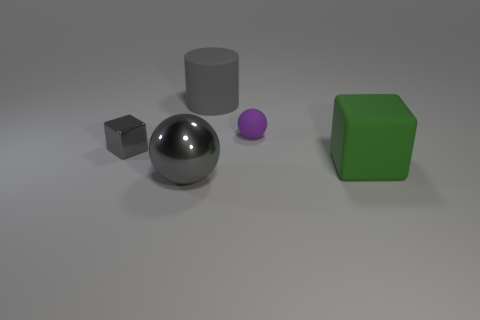Add 3 big blocks. How many objects exist? 8 Subtract all spheres. How many objects are left? 3 Subtract all big things. Subtract all purple objects. How many objects are left? 1 Add 3 large metallic balls. How many large metallic balls are left? 4 Add 4 small purple balls. How many small purple balls exist? 5 Subtract 0 yellow cylinders. How many objects are left? 5 